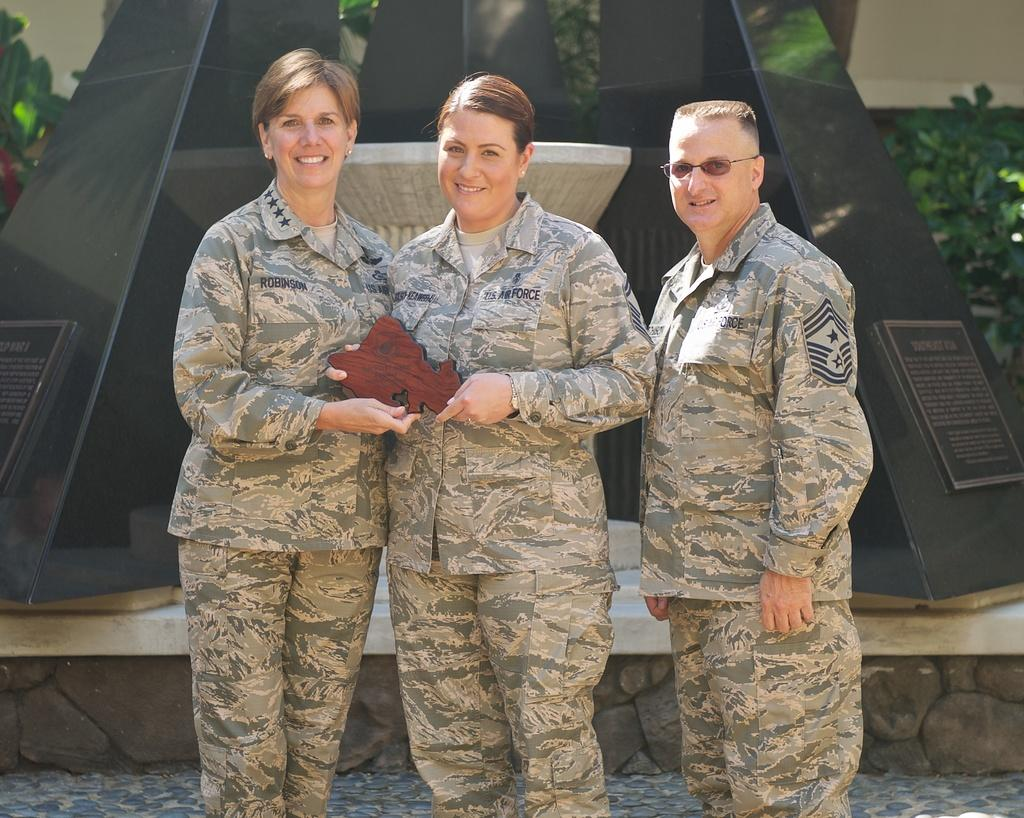How many people are present in the image? There are three people standing in the image. What are two of the people doing? Two people are holding an object. What can be seen in the background of the image? There are black pillars, plants, and a wall in the background of the image. What type of bridge can be seen in the image? There is no bridge present in the image. How many attempts did the people make to lift the object? The facts provided do not mention any attempts or the number of attempts made by the people to lift the object. 